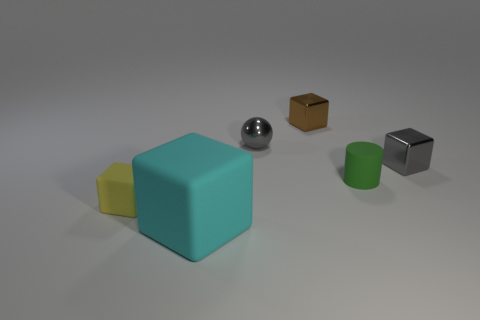There is a tiny yellow object that is the same shape as the large cyan thing; what material is it?
Your response must be concise. Rubber. How many things are either small red balls or cyan matte things?
Your response must be concise. 1. What is the material of the tiny object that is to the right of the cyan matte cube and in front of the gray cube?
Your answer should be very brief. Rubber. Do the yellow rubber block and the green matte cylinder have the same size?
Keep it short and to the point. Yes. There is a rubber object to the left of the block in front of the yellow object; how big is it?
Keep it short and to the point. Small. What number of things are in front of the small sphere and behind the tiny yellow thing?
Offer a very short reply. 2. There is a metallic cube behind the gray metal thing to the right of the gray ball; are there any brown cubes left of it?
Ensure brevity in your answer.  No. The brown object that is the same size as the matte cylinder is what shape?
Make the answer very short. Cube. Are there any metal things of the same color as the metallic ball?
Your response must be concise. Yes. Do the brown object and the tiny yellow matte object have the same shape?
Offer a very short reply. Yes. 